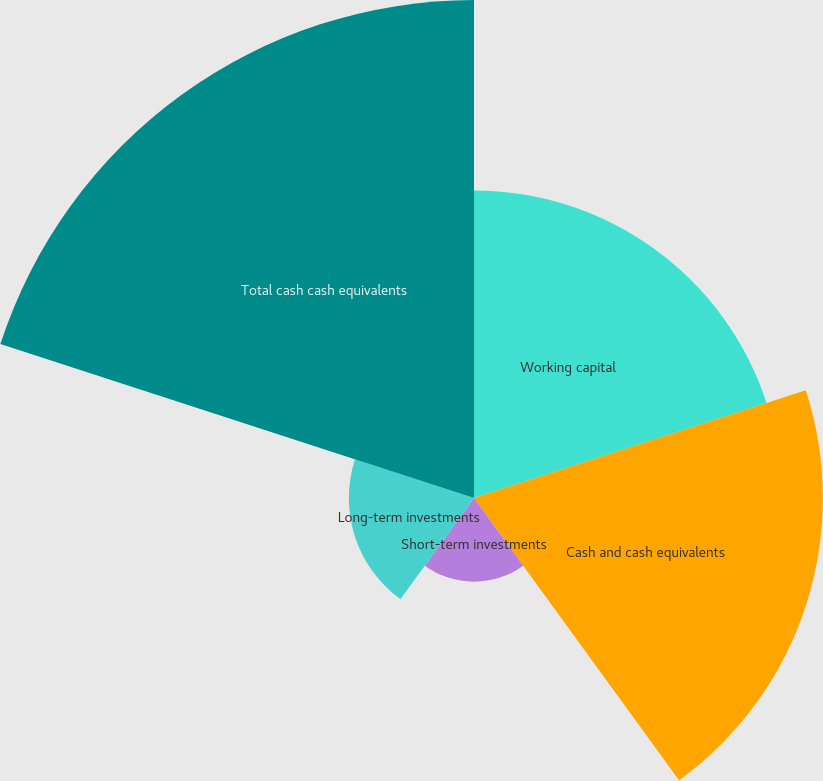Convert chart. <chart><loc_0><loc_0><loc_500><loc_500><pie_chart><fcel>Working capital<fcel>Cash and cash equivalents<fcel>Short-term investments<fcel>Long-term investments<fcel>Total cash cash equivalents<nl><fcel>22.56%<fcel>25.59%<fcel>6.14%<fcel>9.18%<fcel>36.53%<nl></chart> 